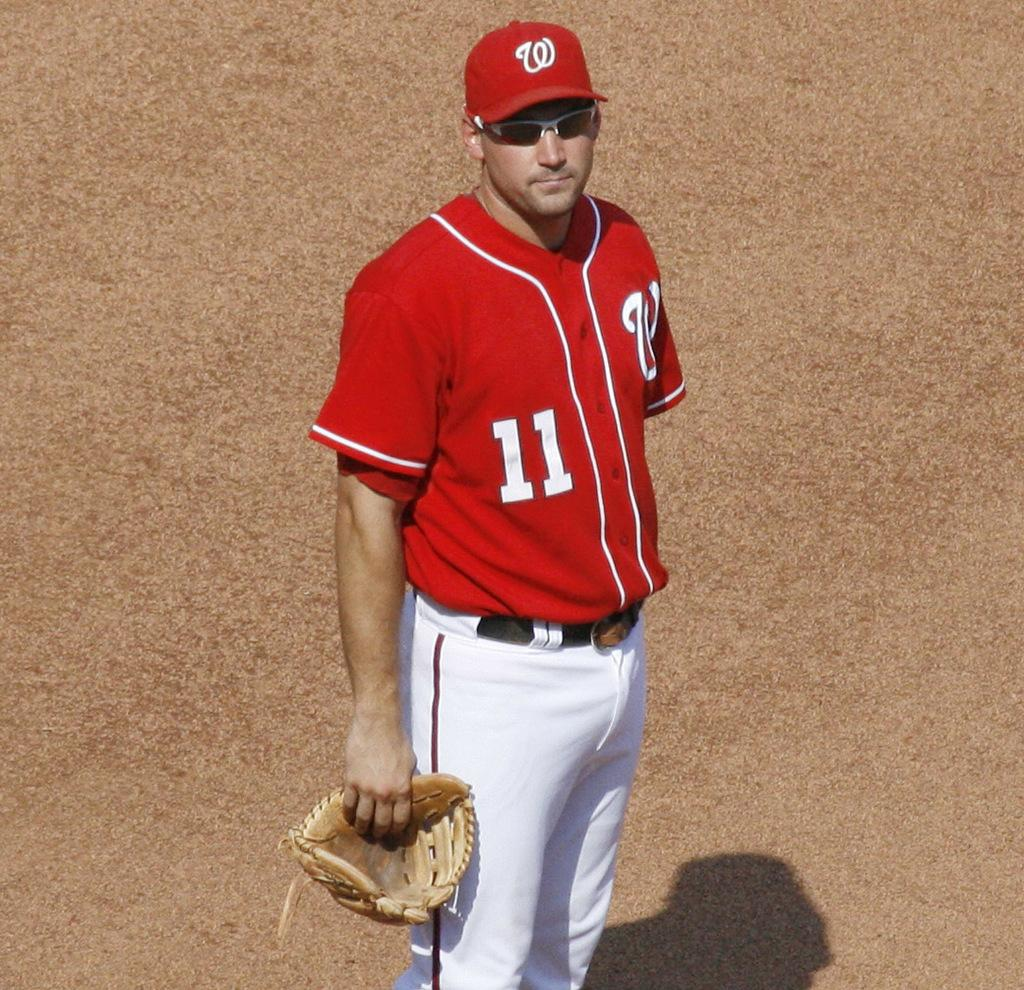<image>
Write a terse but informative summary of the picture. a man in a red number 11 jersey stands on a field 